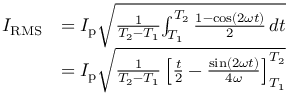Convert formula to latex. <formula><loc_0><loc_0><loc_500><loc_500>{ \begin{array} { r l } { I _ { R M S } } & { = I _ { p } { \sqrt { { \frac { 1 } { T _ { 2 } - T _ { 1 } } } { \int _ { T _ { 1 } } ^ { T _ { 2 } } { \frac { 1 - \cos ( 2 \omega t ) } { 2 } } \, d t } } } } \\ & { = I _ { p } { \sqrt { { \frac { 1 } { T _ { 2 } - T _ { 1 } } } \left [ { \frac { t } { 2 } } - { \frac { \sin ( 2 \omega t ) } { 4 \omega } } \right ] _ { T _ { 1 } } ^ { T _ { 2 } } } } } \end{array} }</formula> 